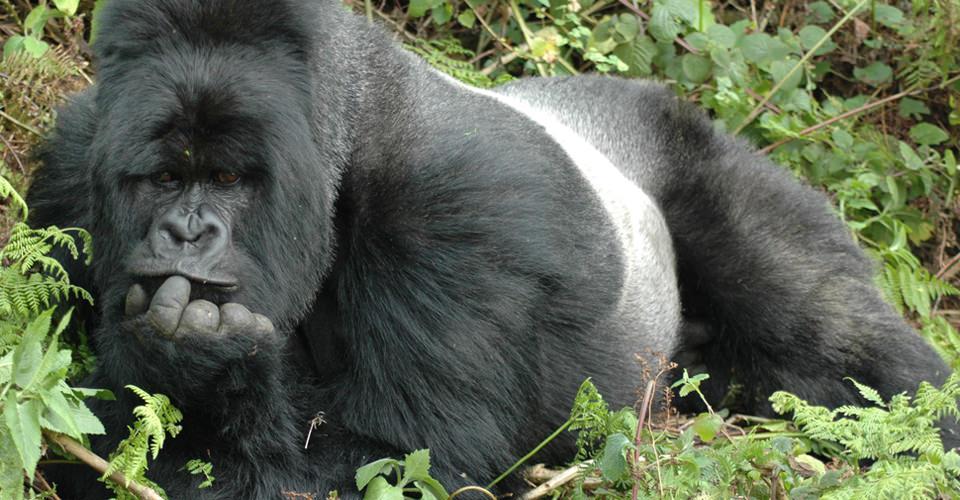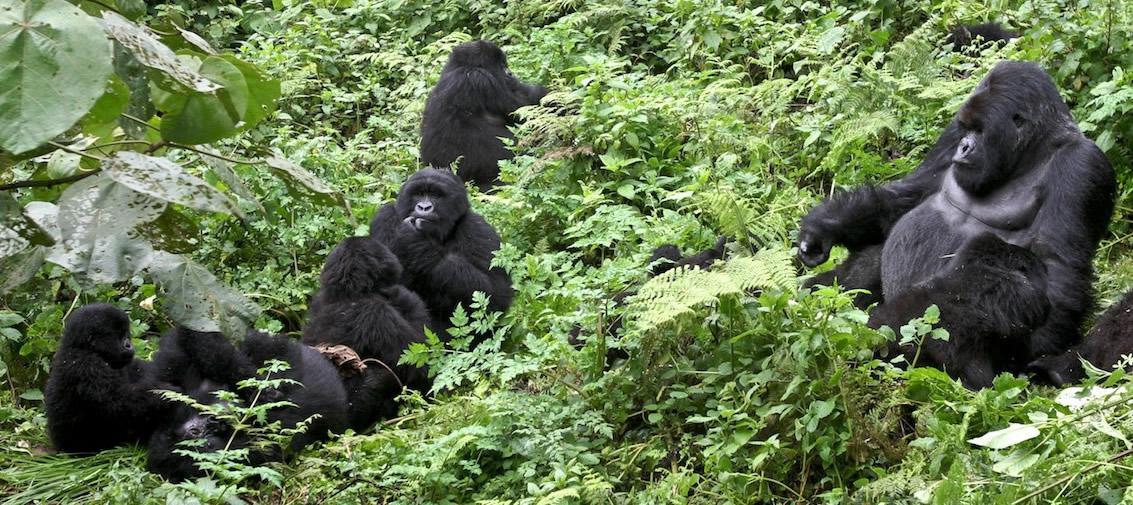The first image is the image on the left, the second image is the image on the right. Examine the images to the left and right. Is the description "The left image shows a single silverback male gorilla, and the right image shows a group of gorillas of various ages and sizes." accurate? Answer yes or no. Yes. The first image is the image on the left, the second image is the image on the right. Given the left and right images, does the statement "The left image contains exactly one silver back gorilla." hold true? Answer yes or no. Yes. 